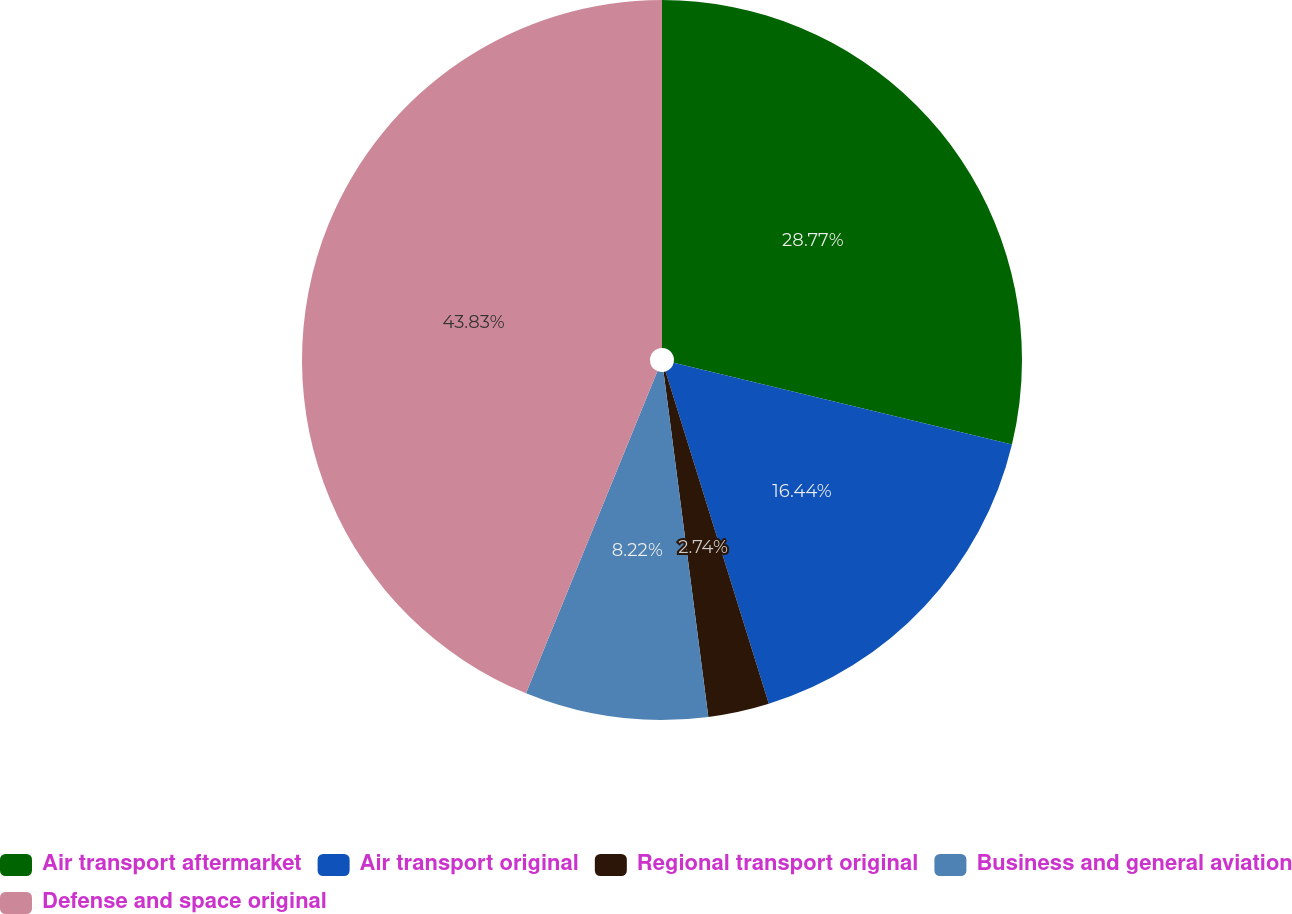Convert chart to OTSL. <chart><loc_0><loc_0><loc_500><loc_500><pie_chart><fcel>Air transport aftermarket<fcel>Air transport original<fcel>Regional transport original<fcel>Business and general aviation<fcel>Defense and space original<nl><fcel>28.77%<fcel>16.44%<fcel>2.74%<fcel>8.22%<fcel>43.84%<nl></chart> 